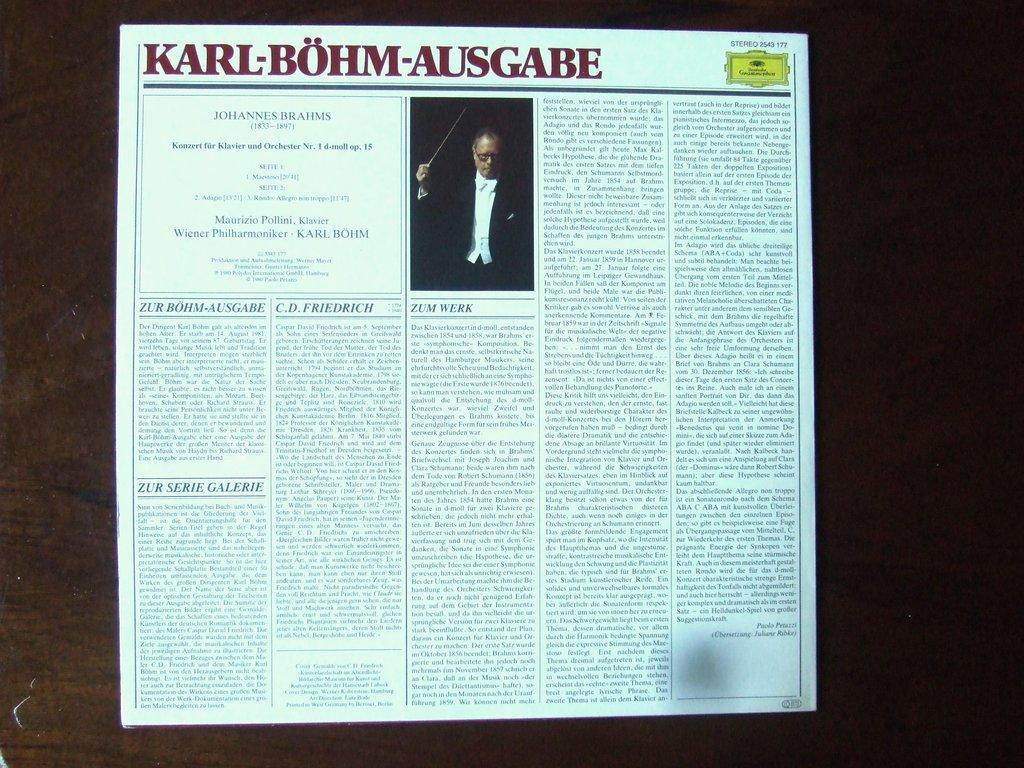<image>
Give a short and clear explanation of the subsequent image. A written article excerpt from a paper relating to Karl-Bohm-Ausgabe 